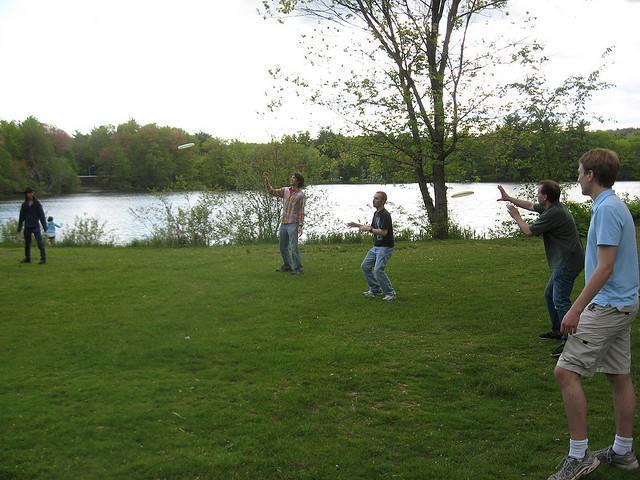How many people are wearing pants?
Give a very brief answer. 4. How many men do you see?
Give a very brief answer. 5. How many people are standing close to the water?
Give a very brief answer. 1. How many people are there?
Give a very brief answer. 4. 